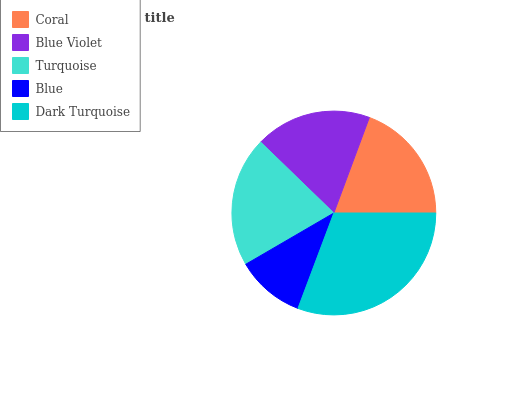Is Blue the minimum?
Answer yes or no. Yes. Is Dark Turquoise the maximum?
Answer yes or no. Yes. Is Blue Violet the minimum?
Answer yes or no. No. Is Blue Violet the maximum?
Answer yes or no. No. Is Coral greater than Blue Violet?
Answer yes or no. Yes. Is Blue Violet less than Coral?
Answer yes or no. Yes. Is Blue Violet greater than Coral?
Answer yes or no. No. Is Coral less than Blue Violet?
Answer yes or no. No. Is Coral the high median?
Answer yes or no. Yes. Is Coral the low median?
Answer yes or no. Yes. Is Dark Turquoise the high median?
Answer yes or no. No. Is Dark Turquoise the low median?
Answer yes or no. No. 